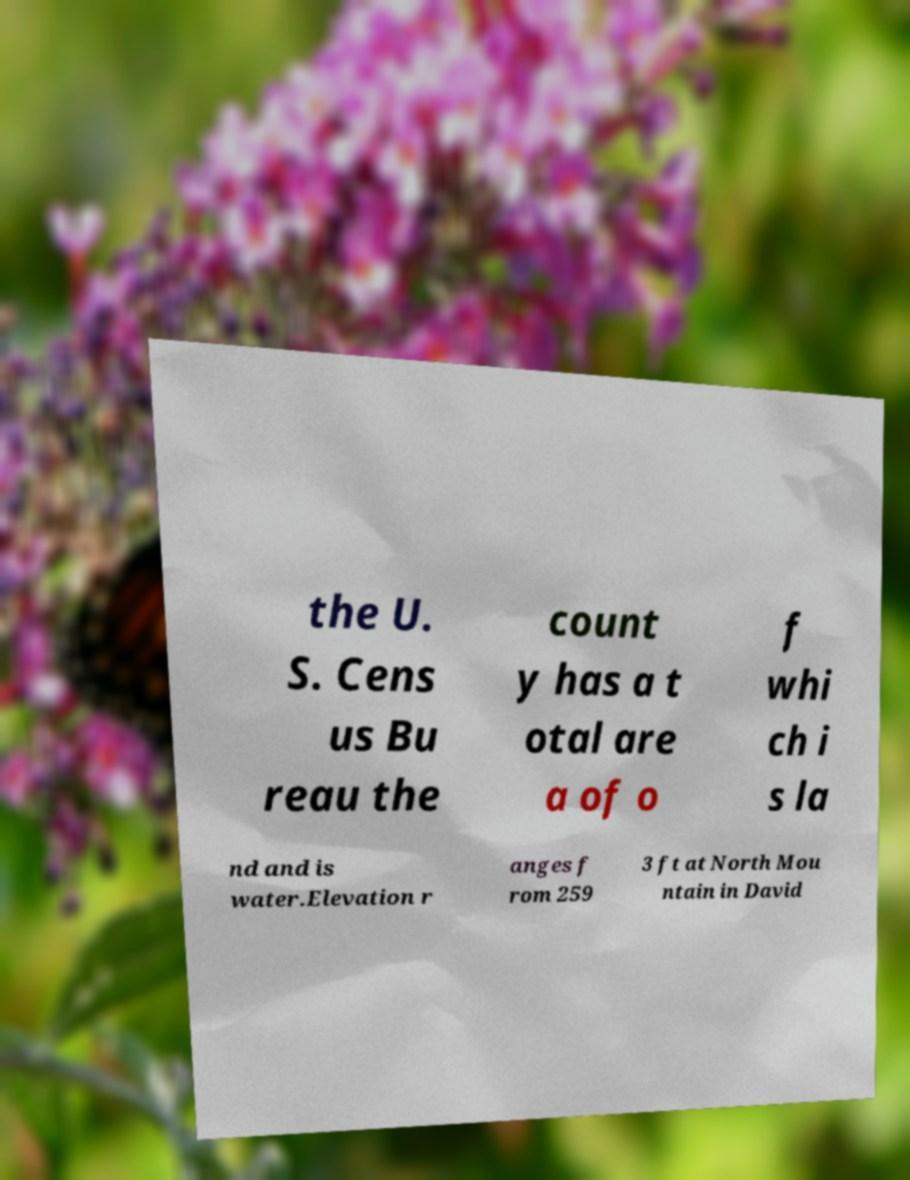Please read and relay the text visible in this image. What does it say? the U. S. Cens us Bu reau the count y has a t otal are a of o f whi ch i s la nd and is water.Elevation r anges f rom 259 3 ft at North Mou ntain in David 